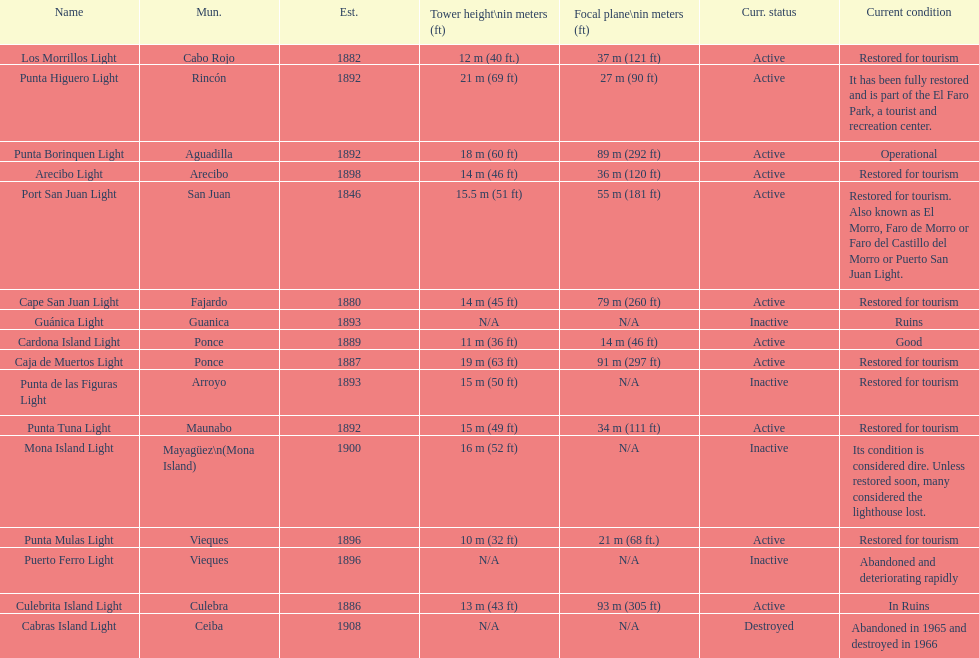How many towers are at least 18 meters tall? 3. Could you parse the entire table as a dict? {'header': ['Name', 'Mun.', 'Est.', 'Tower height\\nin meters (ft)', 'Focal plane\\nin meters (ft)', 'Curr. status', 'Current condition'], 'rows': [['Los Morrillos Light', 'Cabo Rojo', '1882', '12\xa0m (40\xa0ft.)', '37\xa0m (121\xa0ft)', 'Active', 'Restored for tourism'], ['Punta Higuero Light', 'Rincón', '1892', '21\xa0m (69\xa0ft)', '27\xa0m (90\xa0ft)', 'Active', 'It has been fully restored and is part of the El Faro Park, a tourist and recreation center.'], ['Punta Borinquen Light', 'Aguadilla', '1892', '18\xa0m (60\xa0ft)', '89\xa0m (292\xa0ft)', 'Active', 'Operational'], ['Arecibo Light', 'Arecibo', '1898', '14\xa0m (46\xa0ft)', '36\xa0m (120\xa0ft)', 'Active', 'Restored for tourism'], ['Port San Juan Light', 'San Juan', '1846', '15.5\xa0m (51\xa0ft)', '55\xa0m (181\xa0ft)', 'Active', 'Restored for tourism. Also known as El Morro, Faro de Morro or Faro del Castillo del Morro or Puerto San Juan Light.'], ['Cape San Juan Light', 'Fajardo', '1880', '14\xa0m (45\xa0ft)', '79\xa0m (260\xa0ft)', 'Active', 'Restored for tourism'], ['Guánica Light', 'Guanica', '1893', 'N/A', 'N/A', 'Inactive', 'Ruins'], ['Cardona Island Light', 'Ponce', '1889', '11\xa0m (36\xa0ft)', '14\xa0m (46\xa0ft)', 'Active', 'Good'], ['Caja de Muertos Light', 'Ponce', '1887', '19\xa0m (63\xa0ft)', '91\xa0m (297\xa0ft)', 'Active', 'Restored for tourism'], ['Punta de las Figuras Light', 'Arroyo', '1893', '15\xa0m (50\xa0ft)', 'N/A', 'Inactive', 'Restored for tourism'], ['Punta Tuna Light', 'Maunabo', '1892', '15\xa0m (49\xa0ft)', '34\xa0m (111\xa0ft)', 'Active', 'Restored for tourism'], ['Mona Island Light', 'Mayagüez\\n(Mona Island)', '1900', '16\xa0m (52\xa0ft)', 'N/A', 'Inactive', 'Its condition is considered dire. Unless restored soon, many considered the lighthouse lost.'], ['Punta Mulas Light', 'Vieques', '1896', '10\xa0m (32\xa0ft)', '21\xa0m (68\xa0ft.)', 'Active', 'Restored for tourism'], ['Puerto Ferro Light', 'Vieques', '1896', 'N/A', 'N/A', 'Inactive', 'Abandoned and deteriorating rapidly'], ['Culebrita Island Light', 'Culebra', '1886', '13\xa0m (43\xa0ft)', '93\xa0m (305\xa0ft)', 'Active', 'In Ruins'], ['Cabras Island Light', 'Ceiba', '1908', 'N/A', 'N/A', 'Destroyed', 'Abandoned in 1965 and destroyed in 1966']]} 